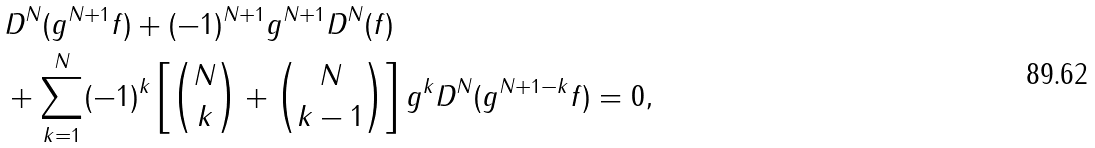Convert formula to latex. <formula><loc_0><loc_0><loc_500><loc_500>& D ^ { N } ( g ^ { N + 1 } f ) + ( - 1 ) ^ { N + 1 } g ^ { N + 1 } D ^ { N } ( f ) \\ & + \sum _ { k = 1 } ^ { N } ( - 1 ) ^ { k } \left [ \binom { N } { k } + \binom { N } { k - 1 } \right ] g ^ { k } D ^ { N } ( g ^ { N + 1 - k } f ) = 0 ,</formula> 